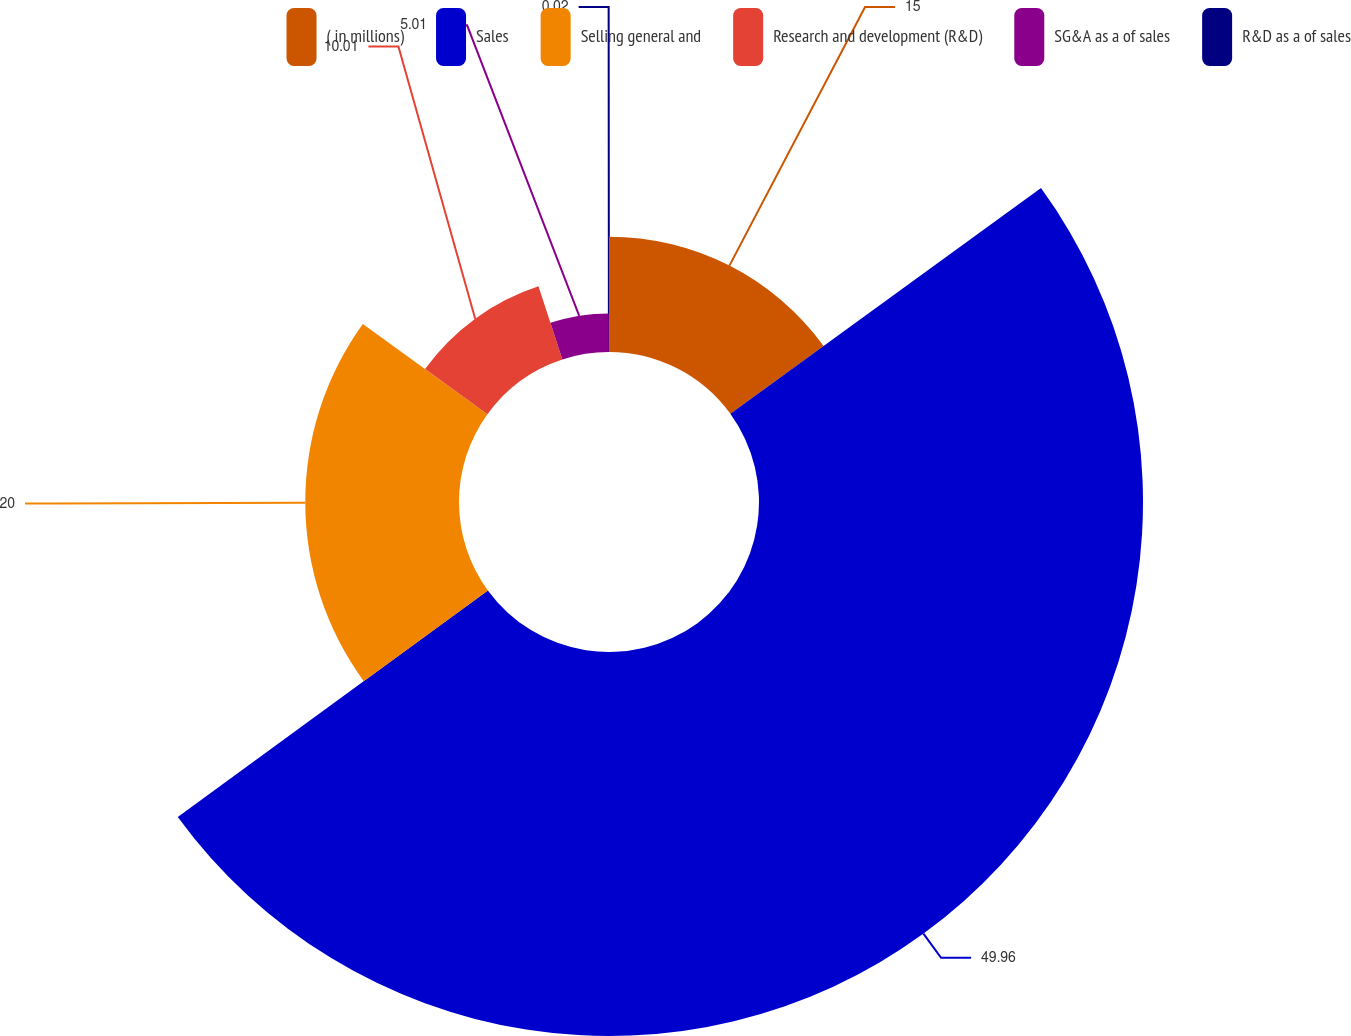Convert chart. <chart><loc_0><loc_0><loc_500><loc_500><pie_chart><fcel>( in millions)<fcel>Sales<fcel>Selling general and<fcel>Research and development (R&D)<fcel>SG&A as a of sales<fcel>R&D as a of sales<nl><fcel>15.0%<fcel>49.96%<fcel>20.0%<fcel>10.01%<fcel>5.01%<fcel>0.02%<nl></chart> 